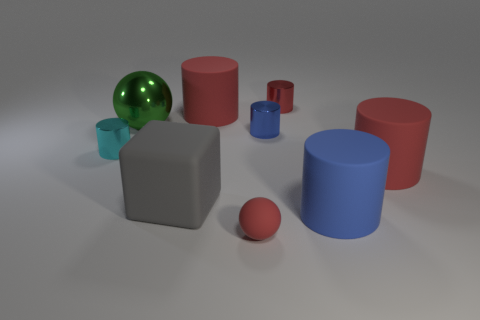How many cylinders are either tiny cyan things or tiny shiny objects?
Make the answer very short. 3. What size is the ball that is made of the same material as the cyan thing?
Provide a succinct answer. Large. What number of rubber cylinders have the same color as the tiny sphere?
Keep it short and to the point. 2. Are there any small cyan cylinders to the left of the rubber sphere?
Offer a terse response. Yes. There is a tiny blue metal thing; is its shape the same as the small red thing to the left of the blue shiny thing?
Offer a very short reply. No. What number of things are either small things that are in front of the big blue thing or tiny cyan cylinders?
Provide a succinct answer. 2. How many small things are behind the large green shiny ball and on the left side of the large rubber block?
Your response must be concise. 0. How many things are either blue objects behind the blue rubber cylinder or shiny objects left of the gray rubber block?
Your answer should be very brief. 3. What number of other objects are the same shape as the big green metal thing?
Ensure brevity in your answer.  1. There is a metal cylinder that is behind the green metal thing; is it the same color as the tiny sphere?
Your answer should be very brief. Yes. 